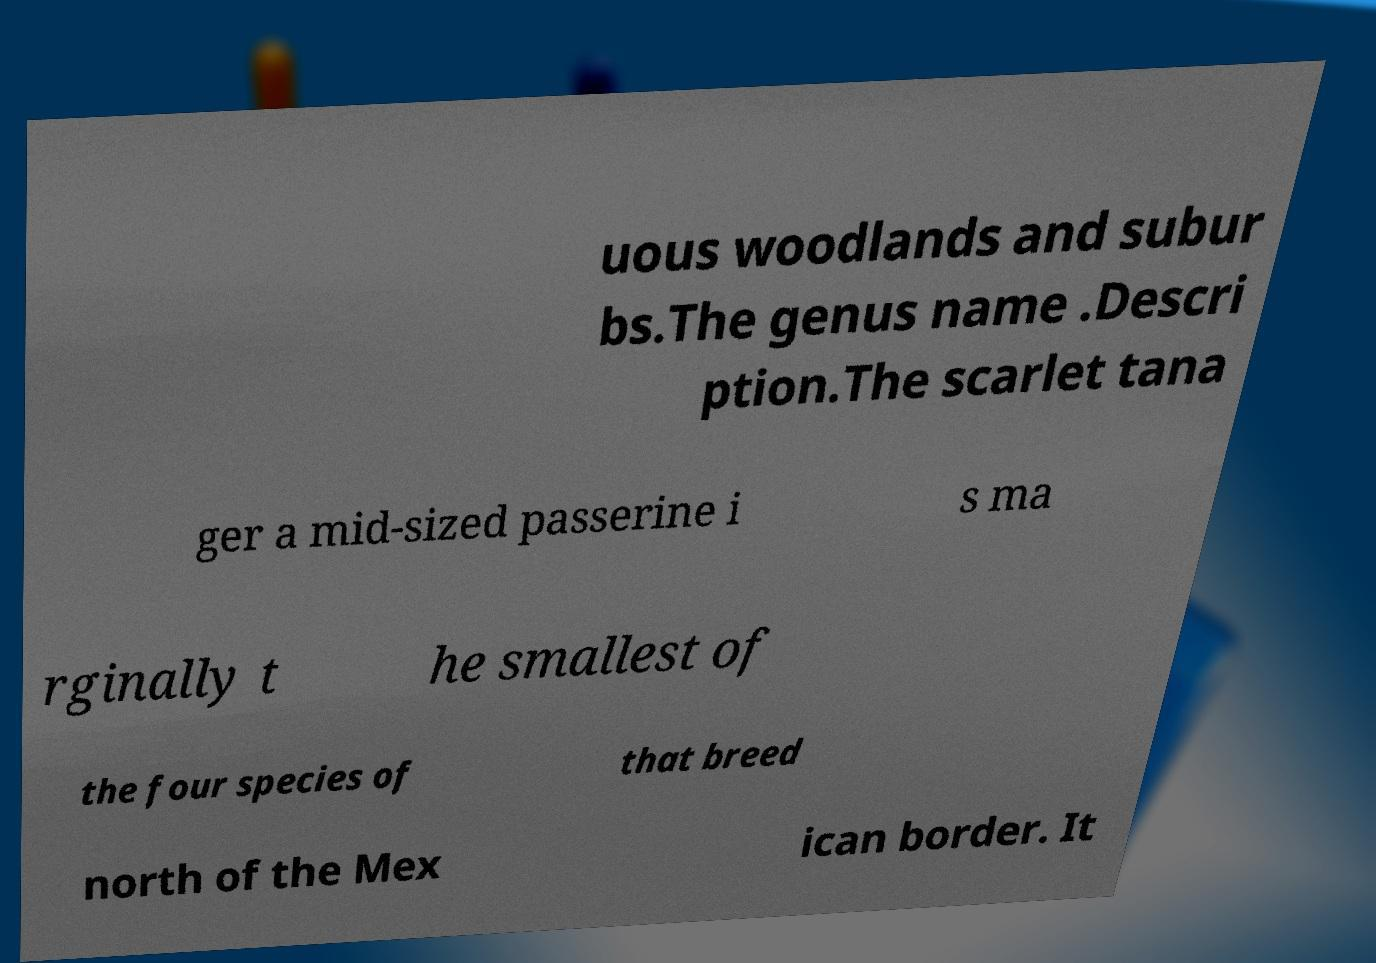Could you assist in decoding the text presented in this image and type it out clearly? uous woodlands and subur bs.The genus name .Descri ption.The scarlet tana ger a mid-sized passerine i s ma rginally t he smallest of the four species of that breed north of the Mex ican border. It 